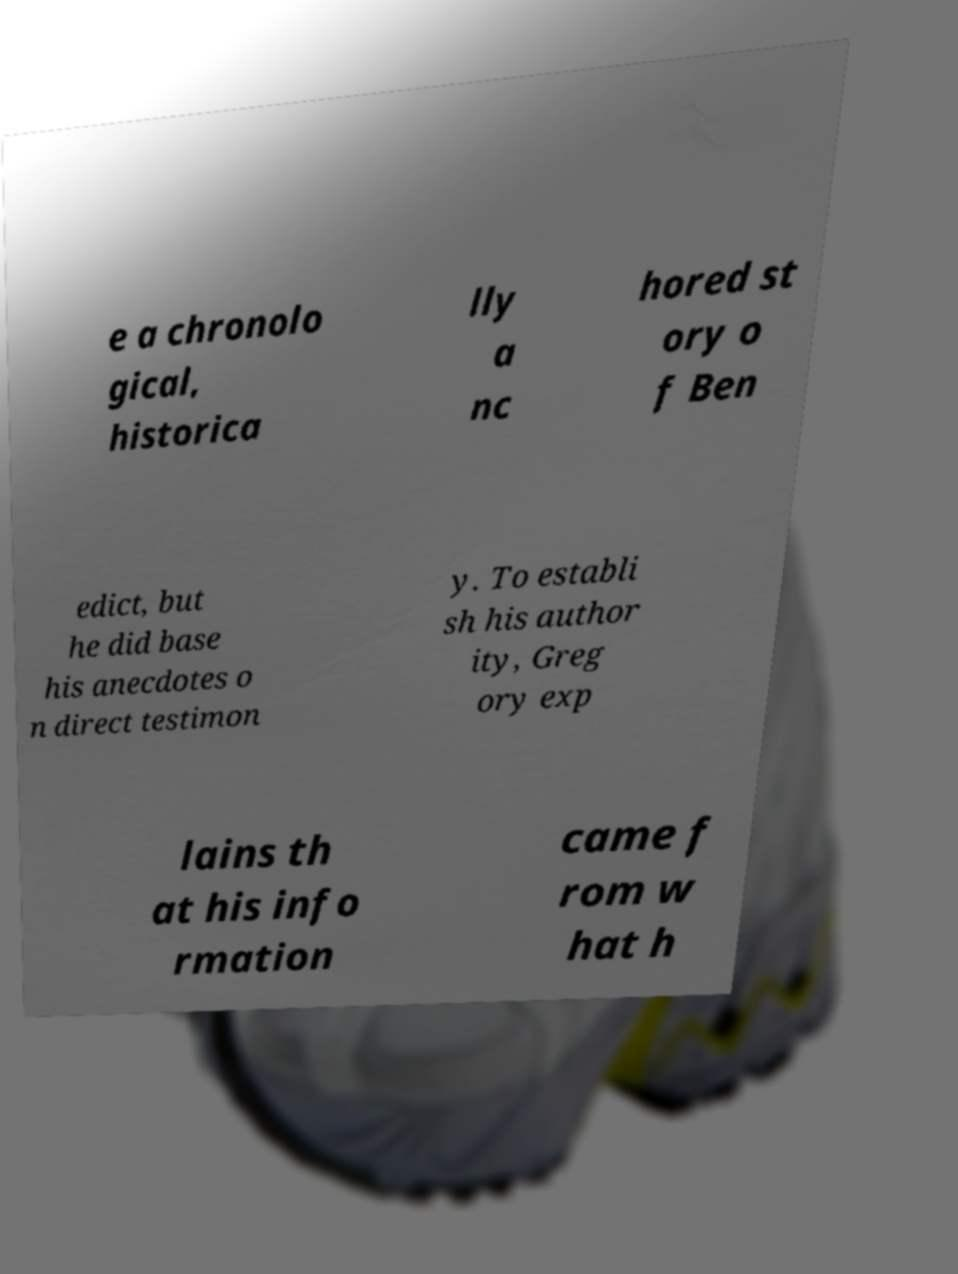Could you assist in decoding the text presented in this image and type it out clearly? e a chronolo gical, historica lly a nc hored st ory o f Ben edict, but he did base his anecdotes o n direct testimon y. To establi sh his author ity, Greg ory exp lains th at his info rmation came f rom w hat h 